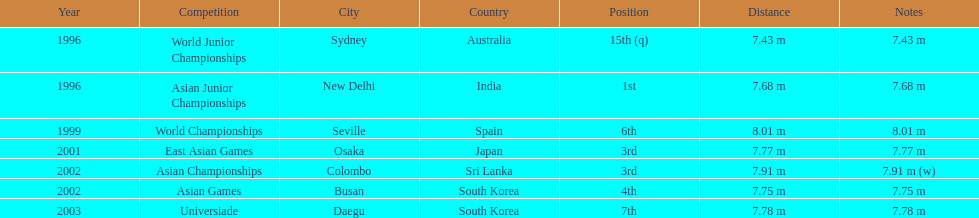How many times did his jump surpass 7.70 m? 5. 